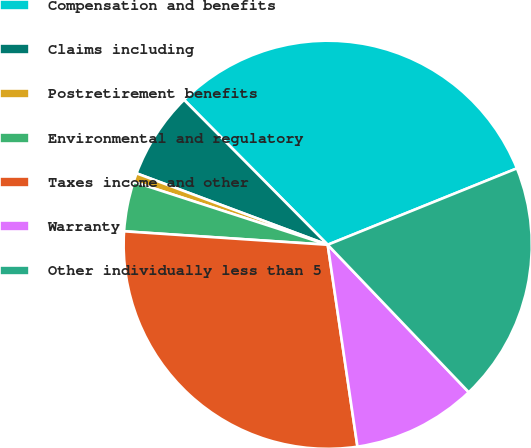<chart> <loc_0><loc_0><loc_500><loc_500><pie_chart><fcel>Compensation and benefits<fcel>Claims including<fcel>Postretirement benefits<fcel>Environmental and regulatory<fcel>Taxes income and other<fcel>Warranty<fcel>Other individually less than 5<nl><fcel>31.32%<fcel>6.88%<fcel>0.7%<fcel>3.94%<fcel>28.38%<fcel>9.82%<fcel>18.96%<nl></chart> 